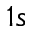<formula> <loc_0><loc_0><loc_500><loc_500>1 s</formula> 